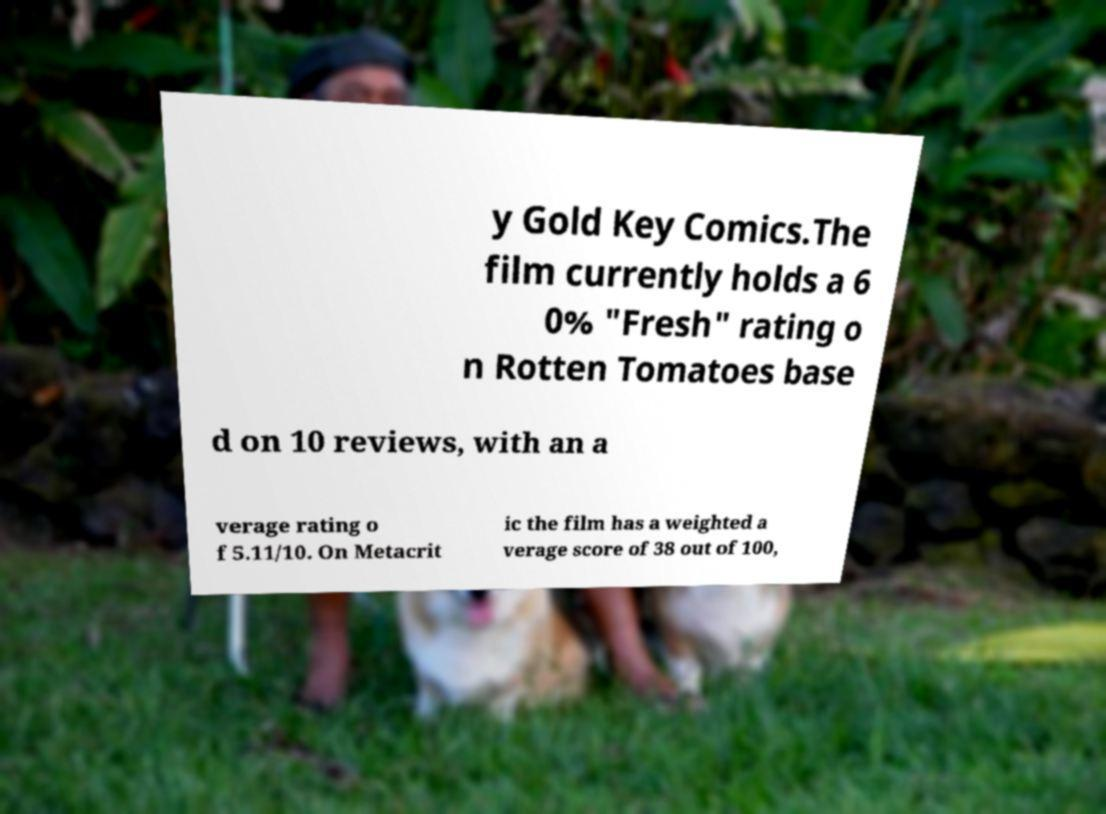Could you extract and type out the text from this image? y Gold Key Comics.The film currently holds a 6 0% "Fresh" rating o n Rotten Tomatoes base d on 10 reviews, with an a verage rating o f 5.11/10. On Metacrit ic the film has a weighted a verage score of 38 out of 100, 